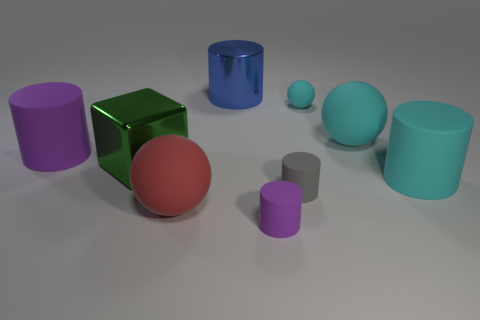Subtract all big red spheres. How many spheres are left? 2 Subtract all gray cylinders. How many cylinders are left? 4 Subtract all gray matte blocks. Subtract all metal cylinders. How many objects are left? 8 Add 5 cubes. How many cubes are left? 6 Add 2 tiny blue shiny spheres. How many tiny blue shiny spheres exist? 2 Add 1 shiny blocks. How many objects exist? 10 Subtract 2 purple cylinders. How many objects are left? 7 Subtract all blocks. How many objects are left? 8 Subtract 5 cylinders. How many cylinders are left? 0 Subtract all blue balls. Subtract all red blocks. How many balls are left? 3 